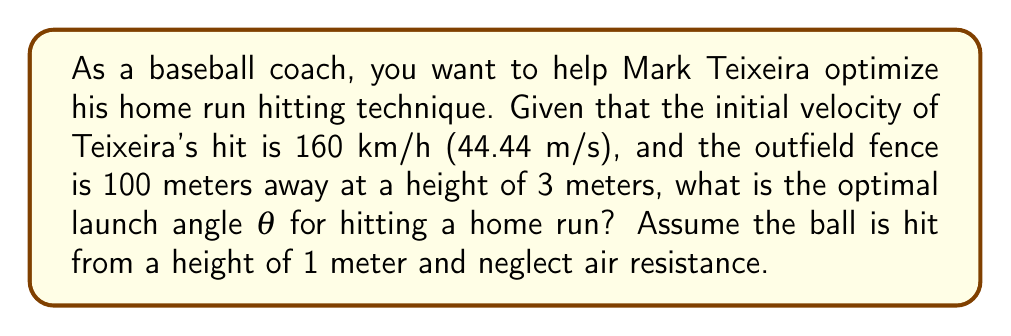Could you help me with this problem? Let's approach this step-by-step using projectile motion equations and trigonometry:

1) The range equation for a projectile launched from height h and landing at height H is:

   $$R = \frac{v_0^2}{g} \left(\cos\theta \sin\theta + \sqrt{(\cos\theta \sin\theta)^2 + \frac{2g(H-h)}{v_0^2}}\right)$$

   Where R is the range, $v_0$ is initial velocity, g is acceleration due to gravity (9.8 m/s²), θ is launch angle, H is final height, and h is initial height.

2) We know:
   R = 100 m
   $v_0$ = 44.44 m/s
   H = 3 m
   h = 1 m
   g = 9.8 m/s²

3) Substituting these values:

   $$100 = \frac{44.44^2}{9.8} \left(\cos\theta \sin\theta + \sqrt{(\cos\theta \sin\theta)^2 + \frac{2(9.8)(3-1)}{44.44^2}}\right)$$

4) Simplify:

   $$100 = 201.3 \left(\cos\theta \sin\theta + \sqrt{(\cos\theta \sin\theta)^2 + 0.00988}\right)$$

5) To maximize range, we need to maximize the right side of the equation. This occurs when:

   $$\cos\theta \sin\theta = \frac{1}{2}\sin(2\theta) = \sqrt{0.00988} = 0.0994$$

6) Solving for θ:

   $$\sin(2\theta) = 0.1988$$
   $$2\theta = \arcsin(0.1988)$$
   $$\theta = \frac{1}{2}\arcsin(0.1988)$$

7) Calculate the value:

   $$\theta ≈ 0.1003 \text{ radians} ≈ 5.75°$$

Therefore, the optimal launch angle for Mark Teixeira to hit a home run under these conditions is approximately 5.75°.
Answer: $5.75°$ 